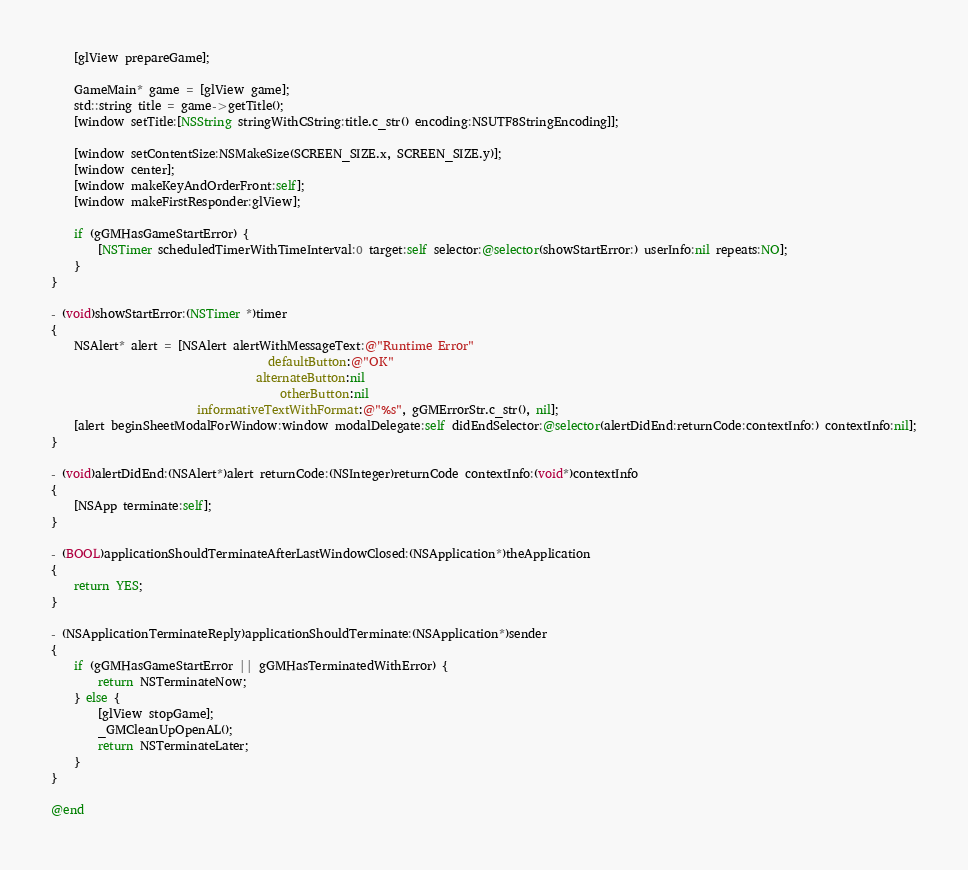<code> <loc_0><loc_0><loc_500><loc_500><_ObjectiveC_>    [glView prepareGame];

    GameMain* game = [glView game];
    std::string title = game->getTitle();
    [window setTitle:[NSString stringWithCString:title.c_str() encoding:NSUTF8StringEncoding]];
    
    [window setContentSize:NSMakeSize(SCREEN_SIZE.x, SCREEN_SIZE.y)];
    [window center];
    [window makeKeyAndOrderFront:self];
    [window makeFirstResponder:glView];
    
    if (gGMHasGameStartError) {
        [NSTimer scheduledTimerWithTimeInterval:0 target:self selector:@selector(showStartError:) userInfo:nil repeats:NO];
    }
}

- (void)showStartError:(NSTimer *)timer
{
    NSAlert* alert = [NSAlert alertWithMessageText:@"Runtime Error"
                                     defaultButton:@"OK"
                                   alternateButton:nil
                                       otherButton:nil
                         informativeTextWithFormat:@"%s", gGMErrorStr.c_str(), nil];
    [alert beginSheetModalForWindow:window modalDelegate:self didEndSelector:@selector(alertDidEnd:returnCode:contextInfo:) contextInfo:nil];
}

- (void)alertDidEnd:(NSAlert*)alert returnCode:(NSInteger)returnCode contextInfo:(void*)contextInfo
{
    [NSApp terminate:self];
}
     
- (BOOL)applicationShouldTerminateAfterLastWindowClosed:(NSApplication*)theApplication
{
    return YES;
}

- (NSApplicationTerminateReply)applicationShouldTerminate:(NSApplication*)sender
{
    if (gGMHasGameStartError || gGMHasTerminatedWithError) {
        return NSTerminateNow;
    } else {
        [glView stopGame];
        _GMCleanUpOpenAL();
        return NSTerminateLater;
    }
}

@end

</code> 